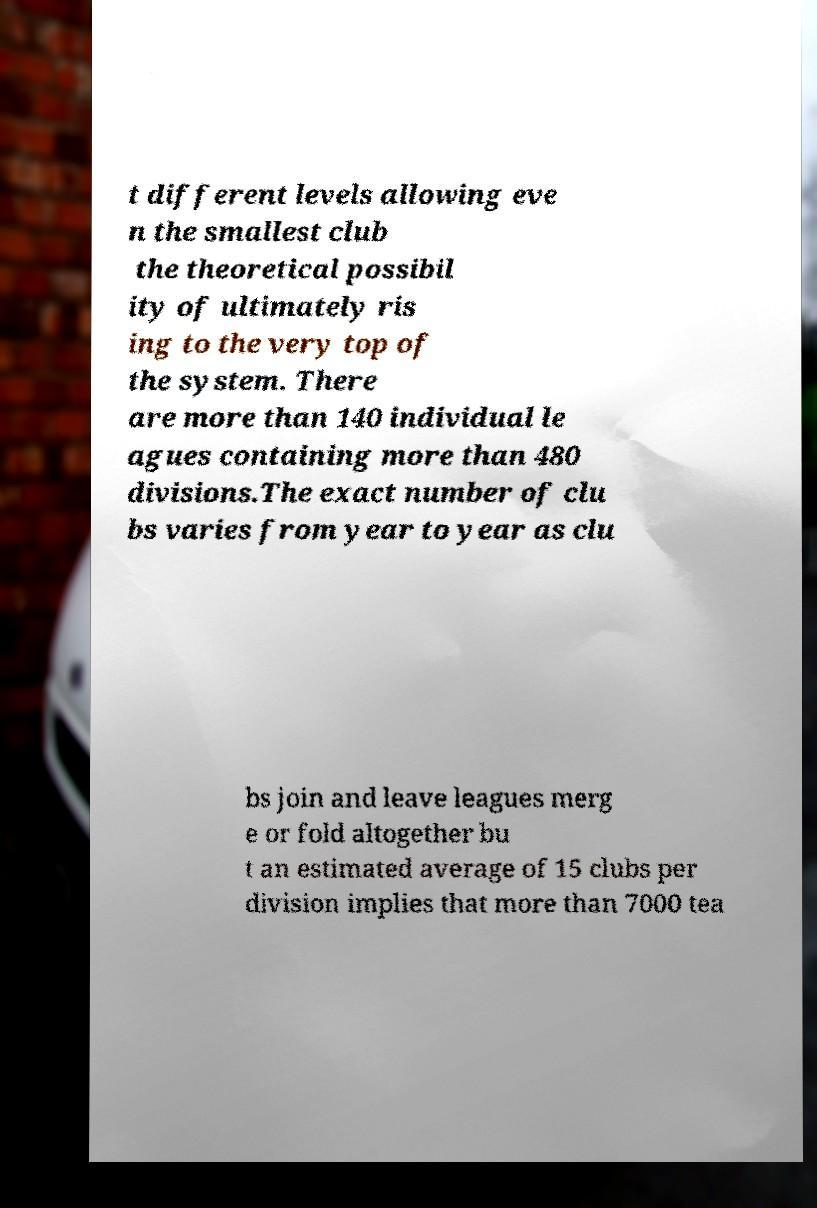There's text embedded in this image that I need extracted. Can you transcribe it verbatim? t different levels allowing eve n the smallest club the theoretical possibil ity of ultimately ris ing to the very top of the system. There are more than 140 individual le agues containing more than 480 divisions.The exact number of clu bs varies from year to year as clu bs join and leave leagues merg e or fold altogether bu t an estimated average of 15 clubs per division implies that more than 7000 tea 